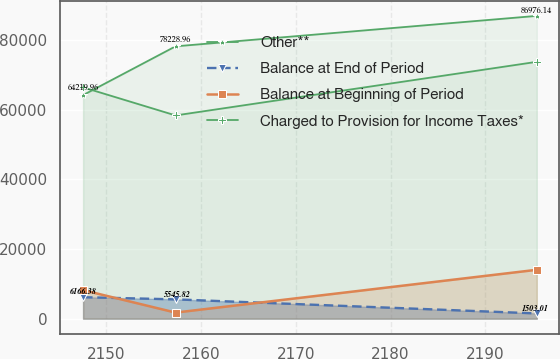<chart> <loc_0><loc_0><loc_500><loc_500><line_chart><ecel><fcel>Other**<fcel>Balance at End of Period<fcel>Balance at Beginning of Period<fcel>Charged to Provision for Income Taxes*<nl><fcel>2147.55<fcel>64220<fcel>6166.38<fcel>8196.67<fcel>66452.3<nl><fcel>2157.31<fcel>78229<fcel>5545.82<fcel>1745.56<fcel>58380.1<nl><fcel>2195.44<fcel>86976.1<fcel>1503.01<fcel>14040.8<fcel>73780.6<nl></chart> 